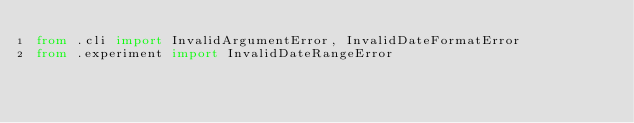Convert code to text. <code><loc_0><loc_0><loc_500><loc_500><_Python_>from .cli import InvalidArgumentError, InvalidDateFormatError
from .experiment import InvalidDateRangeError
</code> 